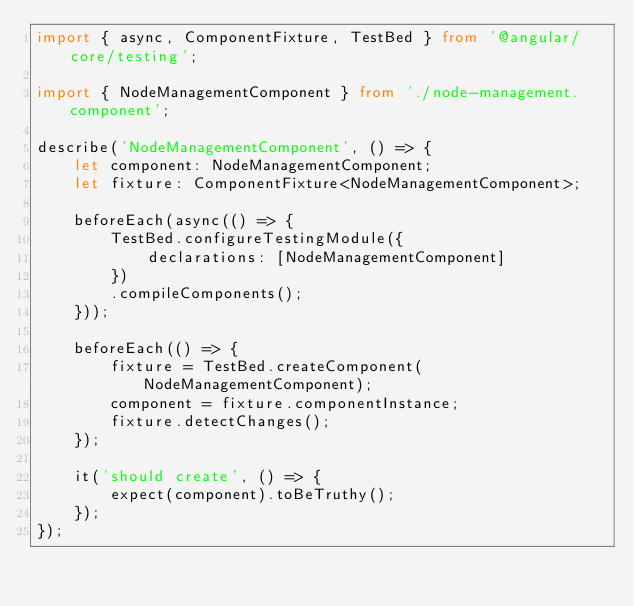<code> <loc_0><loc_0><loc_500><loc_500><_TypeScript_>import { async, ComponentFixture, TestBed } from '@angular/core/testing';

import { NodeManagementComponent } from './node-management.component';

describe('NodeManagementComponent', () => {
    let component: NodeManagementComponent;
    let fixture: ComponentFixture<NodeManagementComponent>;

    beforeEach(async(() => {
        TestBed.configureTestingModule({
            declarations: [NodeManagementComponent]
        })
        .compileComponents();
    }));

    beforeEach(() => {
        fixture = TestBed.createComponent(NodeManagementComponent);
        component = fixture.componentInstance;
        fixture.detectChanges();
    });

    it('should create', () => {
        expect(component).toBeTruthy();
    });
});
</code> 